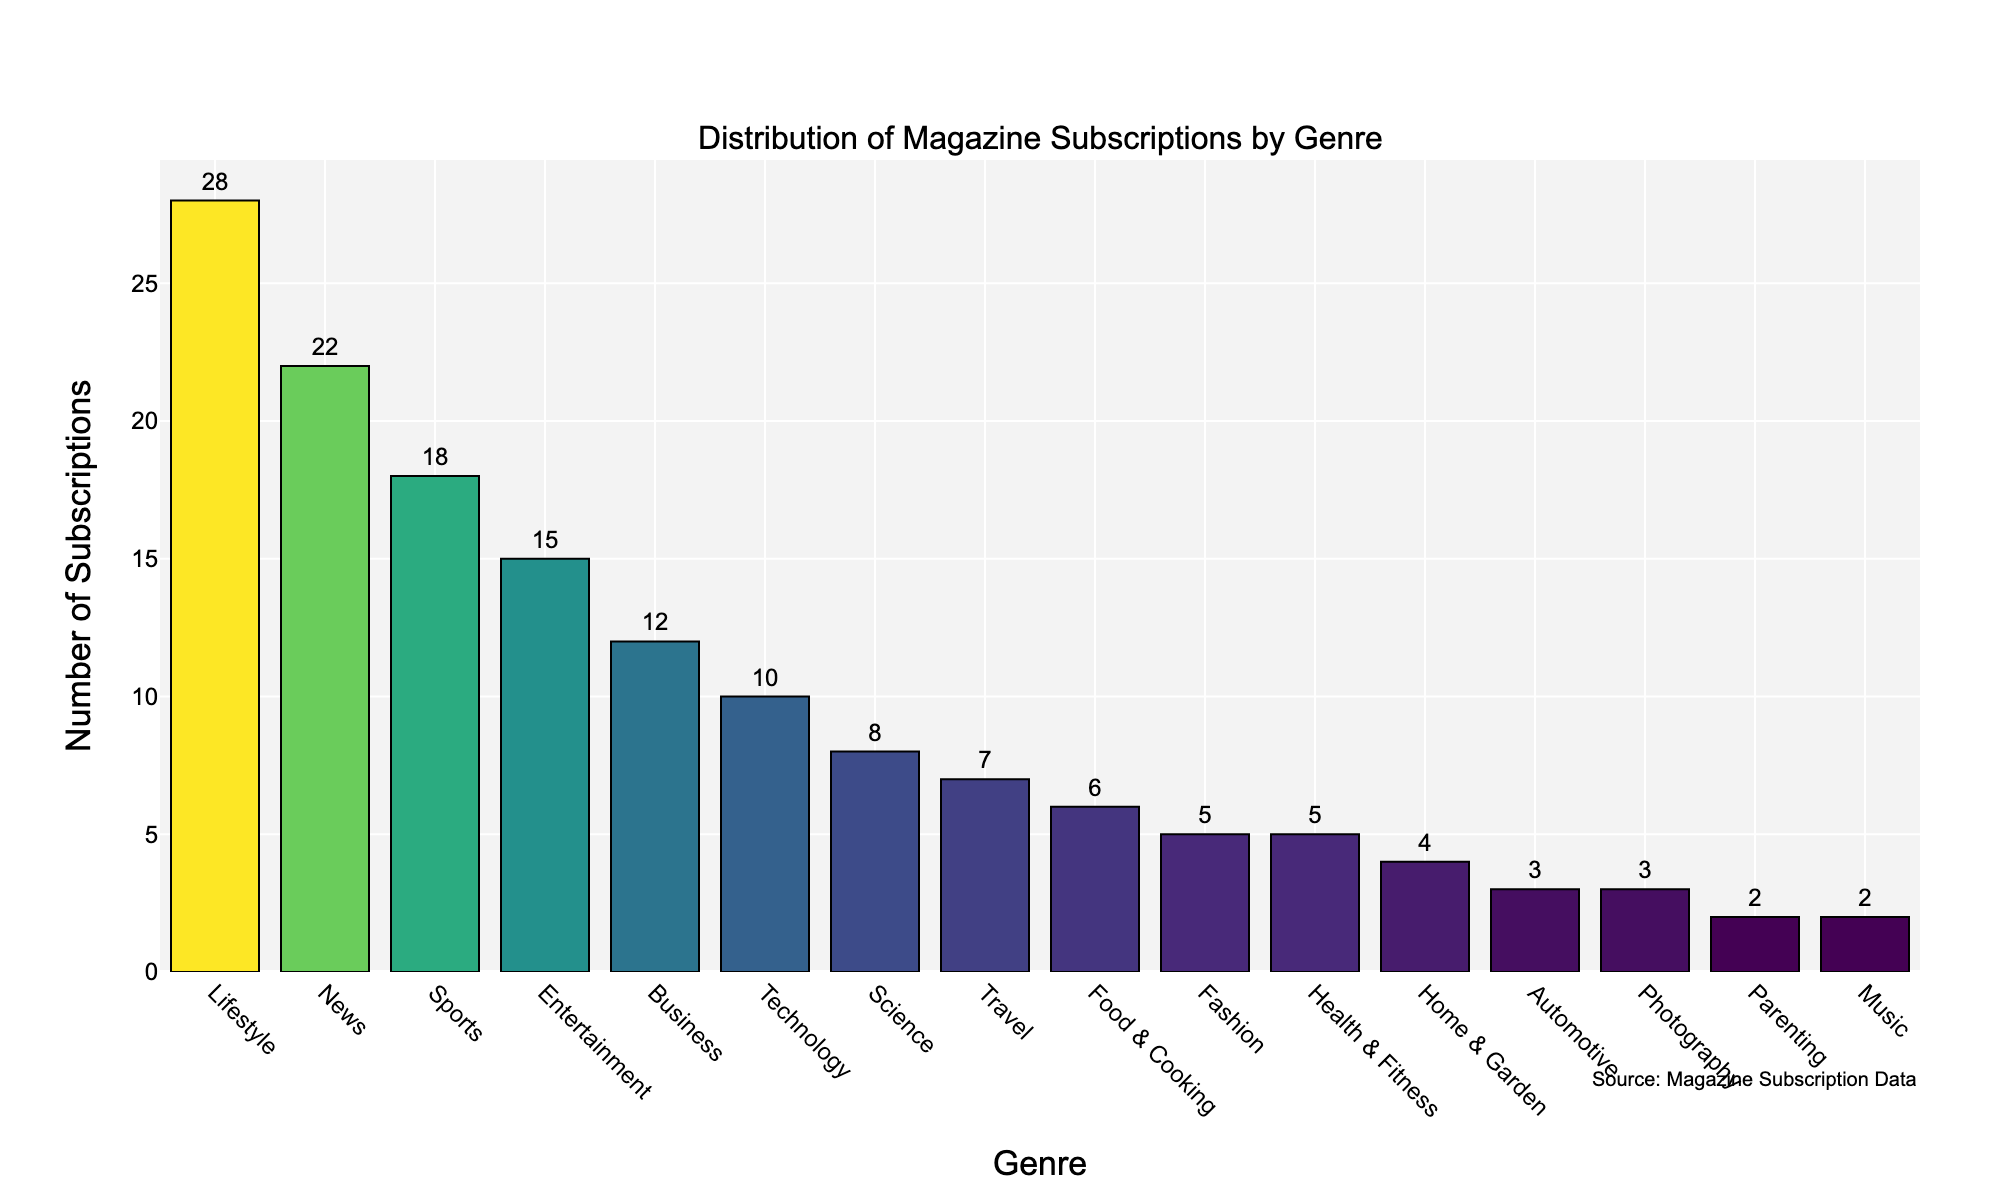What genre has the highest number of subscriptions? The tallest bar in the chart represents the genre with the highest number of subscriptions. In this case, the genre is Lifestyle.
Answer: Lifestyle What is the difference in subscriptions between Lifestyle and News genres? Locate the bar heights for both the Lifestyle and News genres. Lifestyle has 28 subscriptions and News has 22. Subtract the number of subscriptions in News from Lifestyle: 28 - 22
Answer: 6 How many subscriptions are there in total for the top three genres? Add the number of subscriptions for the top three genres. Lifestyle: 28, News: 22, Sports: 18. Total: 28 + 22 + 18
Answer: 68 Which genres have fewer than 10 subscriptions? Identify the bars that have heights less than 10. The genres are Technology, Science, Travel, Food & Cooking, Fashion, Health & Fitness, Home & Garden, Automotive, Photography, Parenting, and Music.
Answer: 10 genres Is the number of subscriptions in Entertainment greater than in Business? Compare the heights of the bars for Entertainment and Business. Entertainment has 15 subscriptions, while Business has 12.
Answer: Yes Calculate the average number of subscriptions across all genres. Add the total number of subscriptions across all genres and then divide by the number of genres. Total subscriptions: 157, Number of genres: 16. Average: 157 / 16
Answer: 9.81 Which genre has the closest number of subscriptions to the median value? Arrange the number of subscriptions in ascending order and identify the middle value(s). The median of the data set is the average of the 8th and 9th values: 7 and 6.5. The genre with closest number of subscriptions to this is Travel with 7.
Answer: Travel Identify the genre with the second least number of subscriptions. Sort the bars from the shortest to the tallest and find the bar that is second from the bottom. In this chart, Parenting has 2, which is the least and Music also has 2.
Answer: Music Which genres combined account for half of the total subscriptions? First, calculate half of the total subscriptions: 157/2 = 78.5. Sum the subscriptions starting from the highest until you reach or exceed 78.5. Lifestyle (28) + News (22) + Sports (18) + Entertainment (15) = 83. These four genres combined account for close to half the total subscriptions.
Answer: Lifestyle, News, Sports, Entertainment How does the number of subscriptions for Automotive compare to Health & Fitness? Locate the bars for Automotive and Health & Fitness. Automotive has 3 subscriptions, while Health & Fitness has 5.
Answer: Automotive has fewer subscriptions 